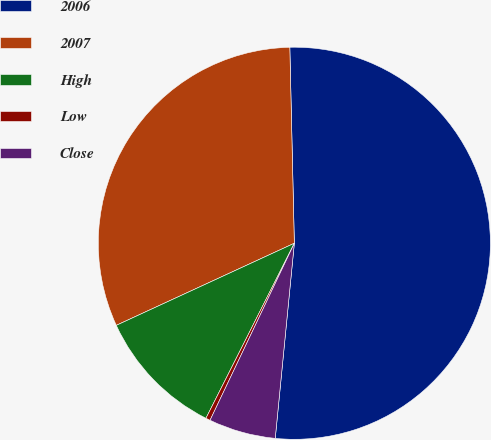Convert chart. <chart><loc_0><loc_0><loc_500><loc_500><pie_chart><fcel>2006<fcel>2007<fcel>High<fcel>Low<fcel>Close<nl><fcel>51.92%<fcel>31.51%<fcel>10.68%<fcel>0.37%<fcel>5.52%<nl></chart> 